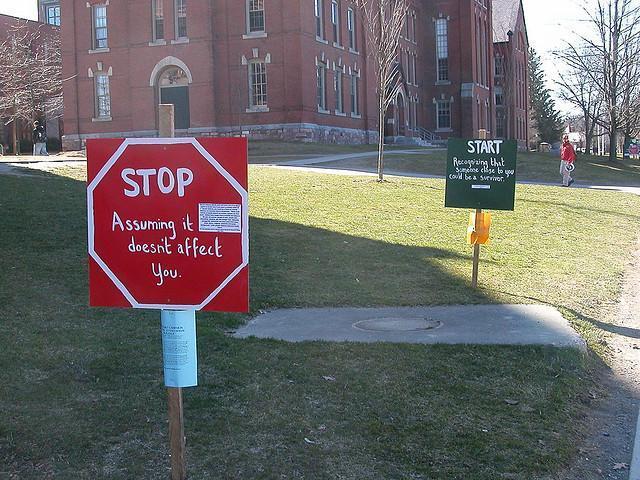How many chairs with cushions are there?
Give a very brief answer. 0. 